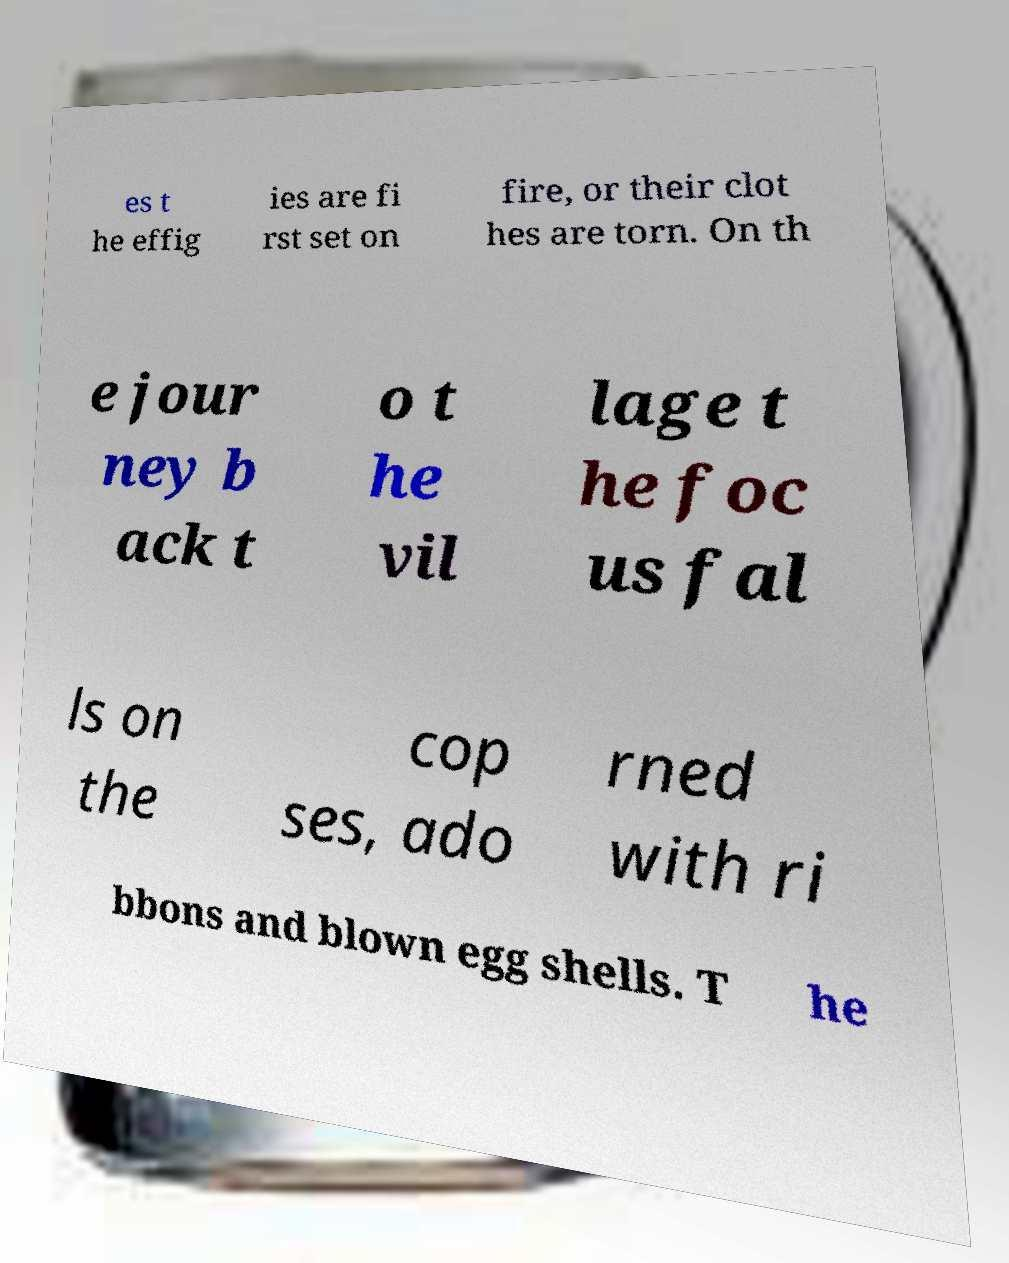Can you read and provide the text displayed in the image?This photo seems to have some interesting text. Can you extract and type it out for me? es t he effig ies are fi rst set on fire, or their clot hes are torn. On th e jour ney b ack t o t he vil lage t he foc us fal ls on the cop ses, ado rned with ri bbons and blown egg shells. T he 